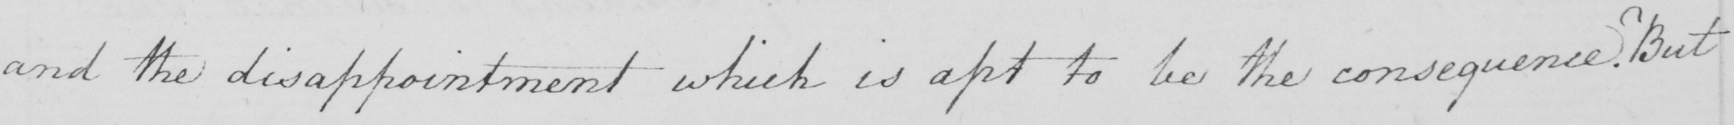What does this handwritten line say? and the disappointment which is apt to be the consequence . But 